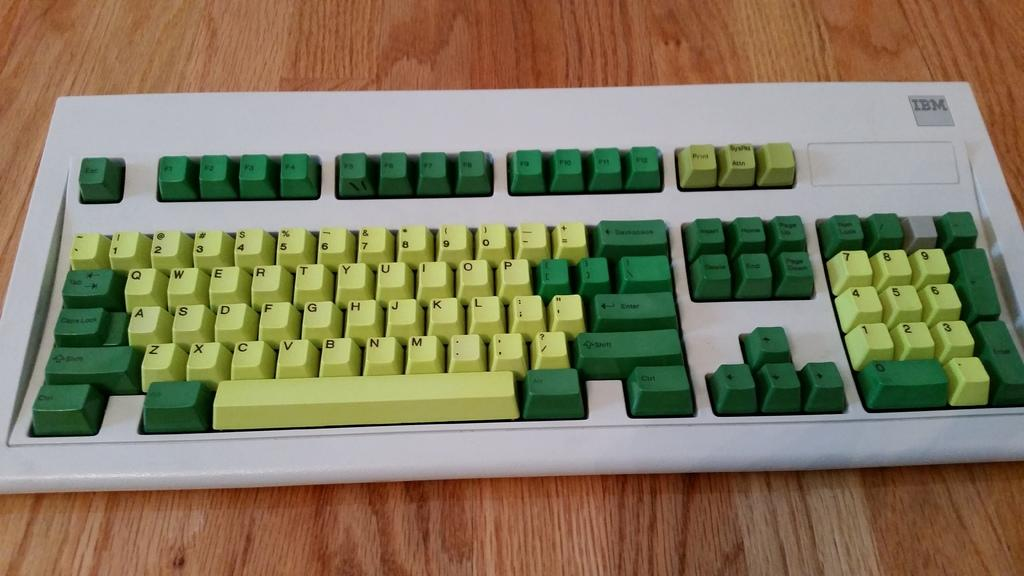<image>
Render a clear and concise summary of the photo. A yellow and green keyboard has a green enter key 